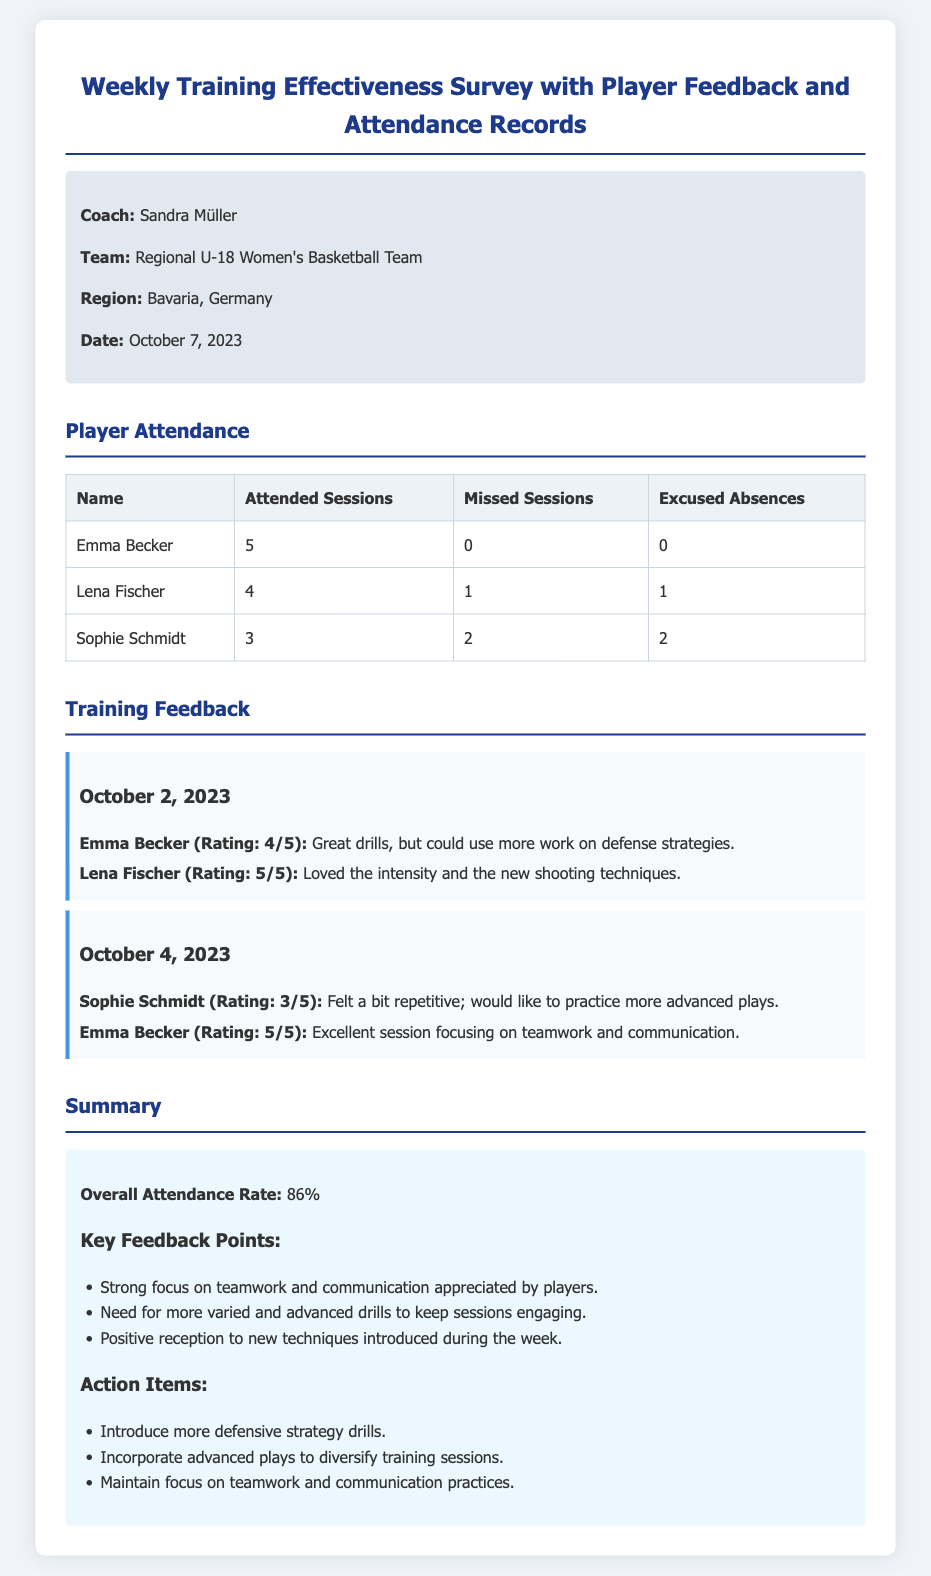What is the name of the coach? The document specifies the coach's name is Sandra Müller.
Answer: Sandra Müller What is the overall attendance rate? The overall attendance rate is explicitly stated in the summary section of the document.
Answer: 86% How many sessions did Sophie Schmidt attend? The attendance table provides the number of sessions attended by each player, including Sophie Schmidt.
Answer: 3 What date is mentioned for the training feedback? The training feedback contains specific dates for sessions; one of them is October 2, 2023.
Answer: October 2, 2023 Which player rated the October 4 session as 5/5? The feedback section indicates that Emma Becker rated the session on October 4, 2023, as 5/5.
Answer: Emma Becker How many excused absences did Lena Fischer have? The attendance table shows the number of excused absences for each player.
Answer: 1 What did players appreciate about the training focus? The summary highlights the players' positive feedback regarding teamwork and communication practices.
Answer: Teamwork and communication What action item is suggested for training? The action items in the summary include introducing more defensive strategy drills.
Answer: More defensive strategy drills How many players attended all sessions? The attendance table lists each player's attended sessions, revealing that only Emma Becker attended all.
Answer: 1 